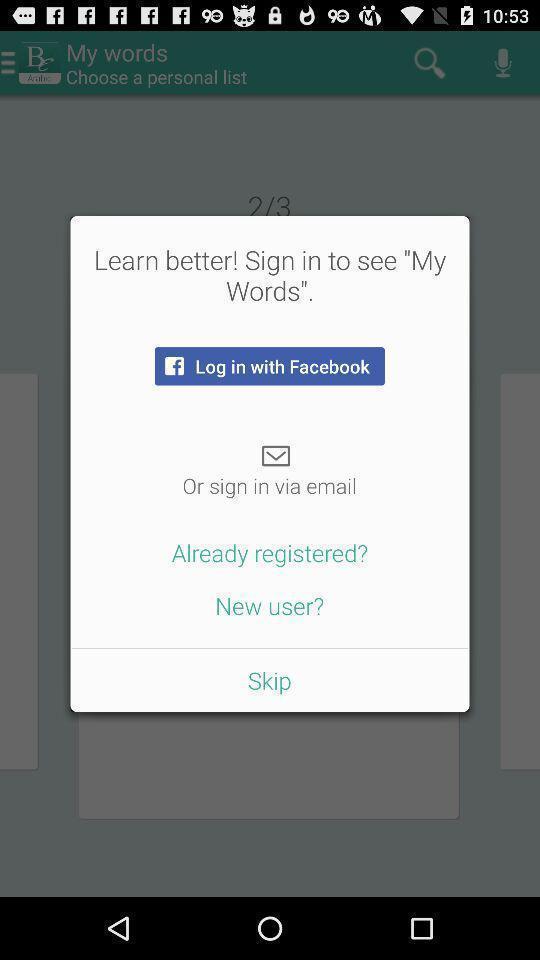What details can you identify in this image? Pop-up showing to login in a learning application. 